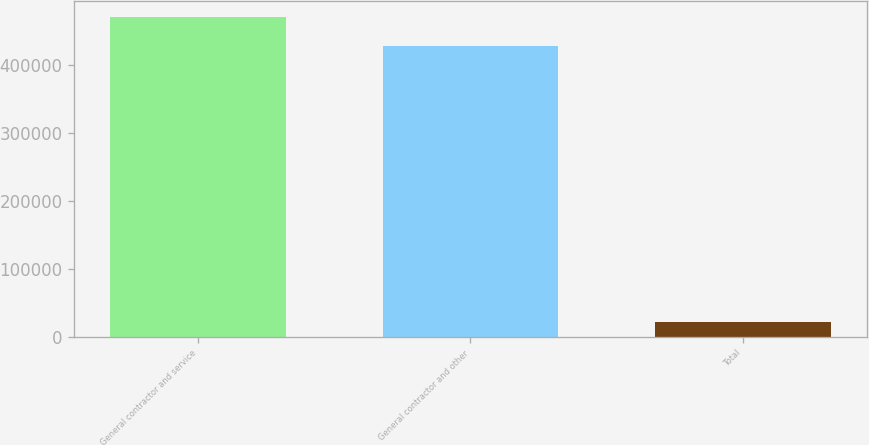Convert chart to OTSL. <chart><loc_0><loc_0><loc_500><loc_500><bar_chart><fcel>General contractor and service<fcel>General contractor and other<fcel>Total<nl><fcel>470433<fcel>427666<fcel>21843<nl></chart> 